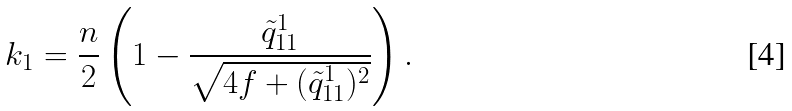<formula> <loc_0><loc_0><loc_500><loc_500>k _ { 1 } = \frac { n } { 2 } \left ( 1 - \frac { \tilde { q } _ { 1 1 } ^ { 1 } } { \sqrt { 4 f + ( \tilde { q } _ { 1 1 } ^ { 1 } ) ^ { 2 } } } \right ) .</formula> 